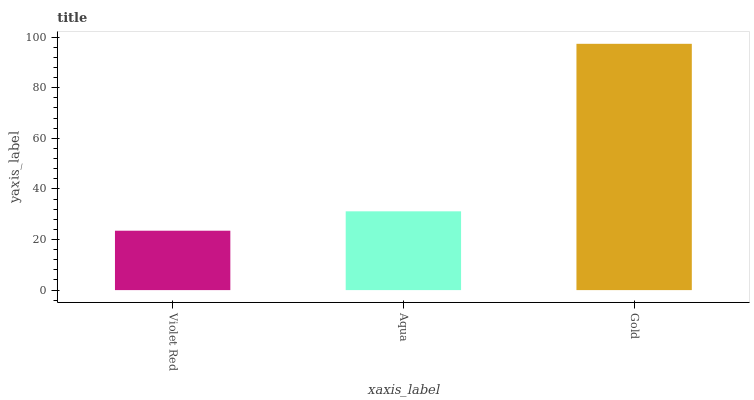Is Violet Red the minimum?
Answer yes or no. Yes. Is Gold the maximum?
Answer yes or no. Yes. Is Aqua the minimum?
Answer yes or no. No. Is Aqua the maximum?
Answer yes or no. No. Is Aqua greater than Violet Red?
Answer yes or no. Yes. Is Violet Red less than Aqua?
Answer yes or no. Yes. Is Violet Red greater than Aqua?
Answer yes or no. No. Is Aqua less than Violet Red?
Answer yes or no. No. Is Aqua the high median?
Answer yes or no. Yes. Is Aqua the low median?
Answer yes or no. Yes. Is Violet Red the high median?
Answer yes or no. No. Is Gold the low median?
Answer yes or no. No. 